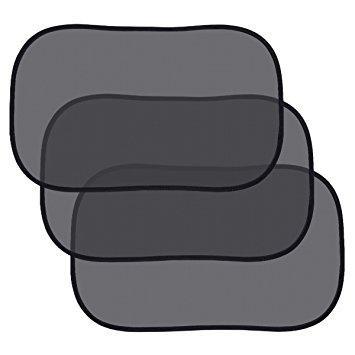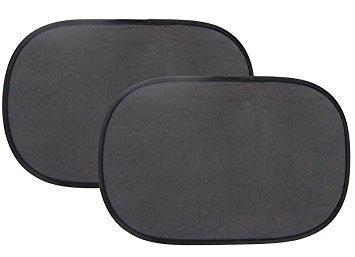The first image is the image on the left, the second image is the image on the right. Given the left and right images, does the statement "The right image shows the vehicle's interior with a shaded window." hold true? Answer yes or no. No. 